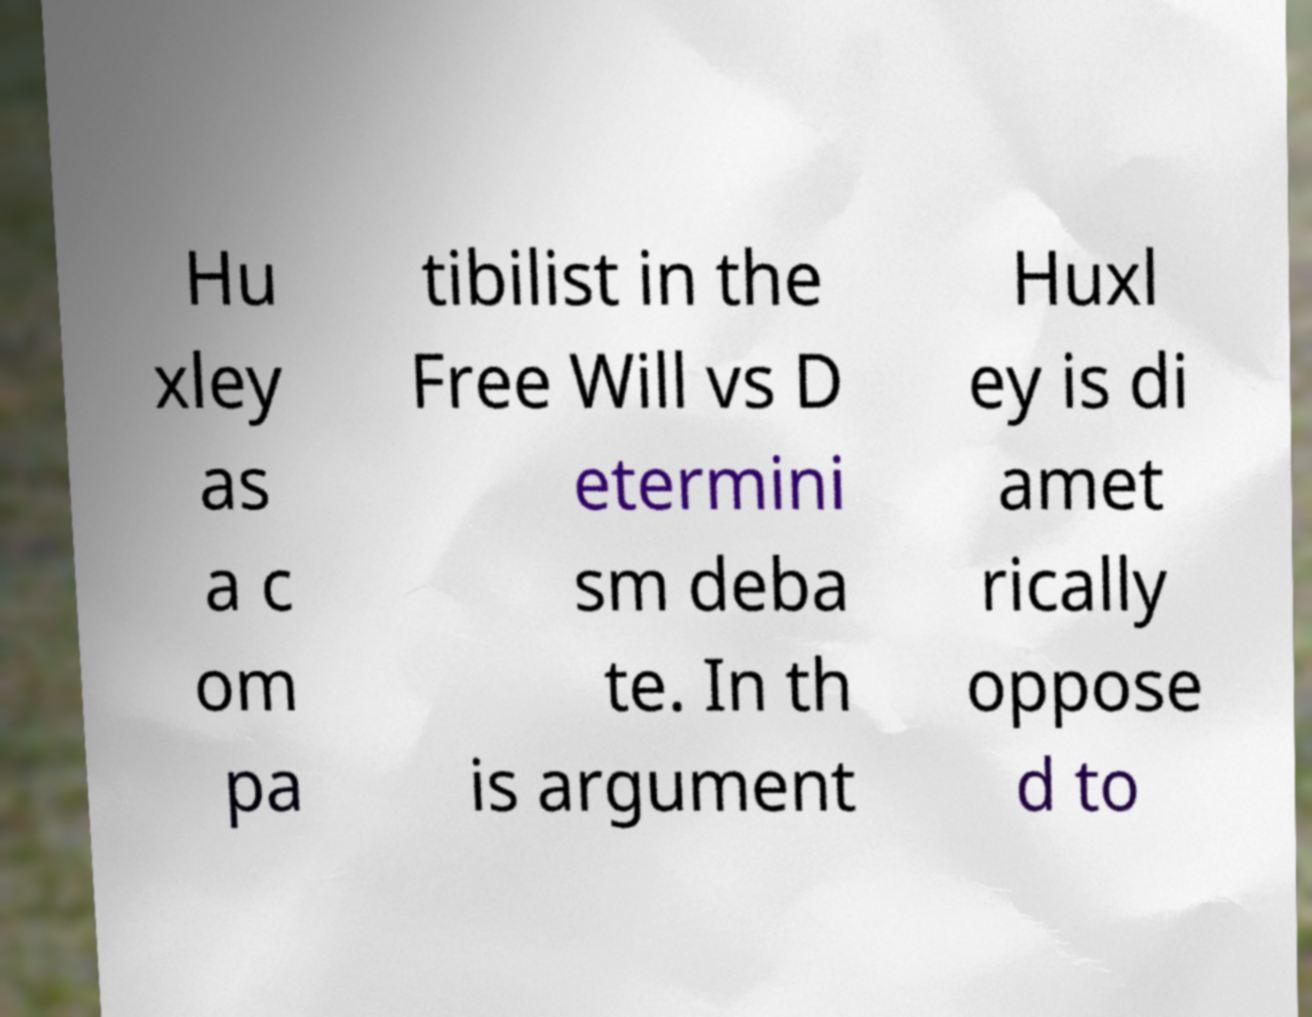There's text embedded in this image that I need extracted. Can you transcribe it verbatim? Hu xley as a c om pa tibilist in the Free Will vs D etermini sm deba te. In th is argument Huxl ey is di amet rically oppose d to 